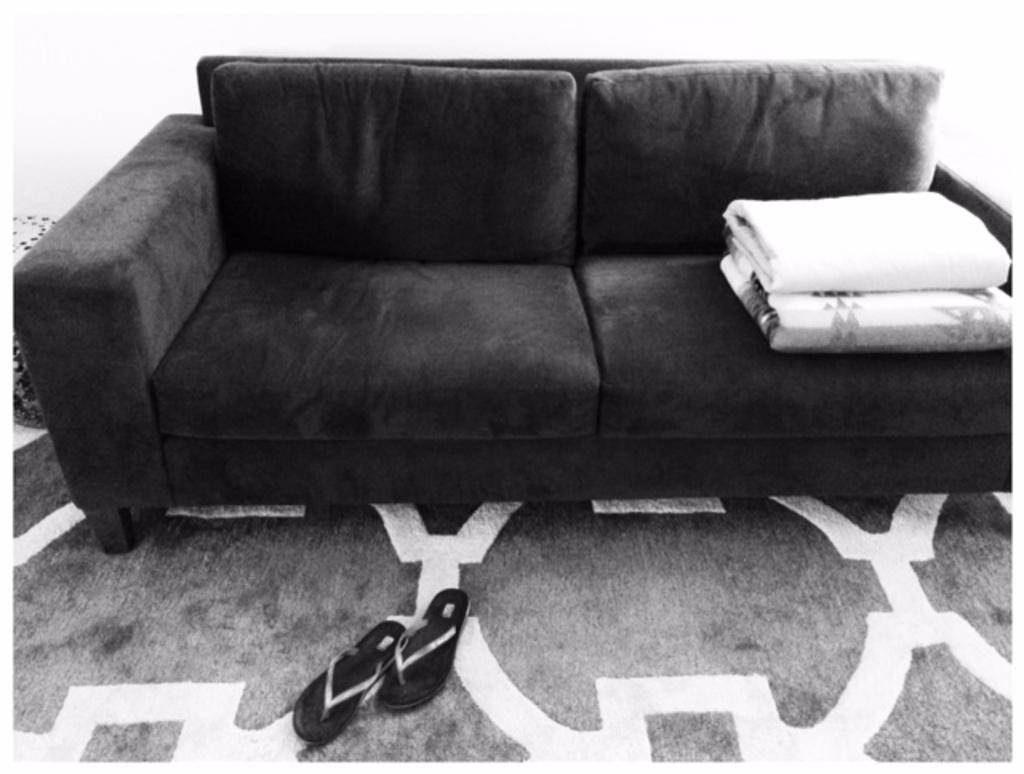What type of furniture is in the image? There is a sofa in the image. What is covering the sofa? There is a blanket on the sofa. What type of footwear is on the floor? There is a pair of slippers on the floor. What type of fish can be seen swimming on the sofa in the image? There is no fish present in the image; it features a sofa with a blanket and a pair of slippers on the floor. 